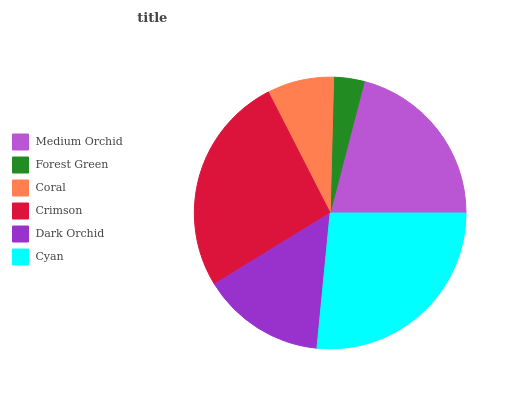Is Forest Green the minimum?
Answer yes or no. Yes. Is Cyan the maximum?
Answer yes or no. Yes. Is Coral the minimum?
Answer yes or no. No. Is Coral the maximum?
Answer yes or no. No. Is Coral greater than Forest Green?
Answer yes or no. Yes. Is Forest Green less than Coral?
Answer yes or no. Yes. Is Forest Green greater than Coral?
Answer yes or no. No. Is Coral less than Forest Green?
Answer yes or no. No. Is Medium Orchid the high median?
Answer yes or no. Yes. Is Dark Orchid the low median?
Answer yes or no. Yes. Is Coral the high median?
Answer yes or no. No. Is Medium Orchid the low median?
Answer yes or no. No. 